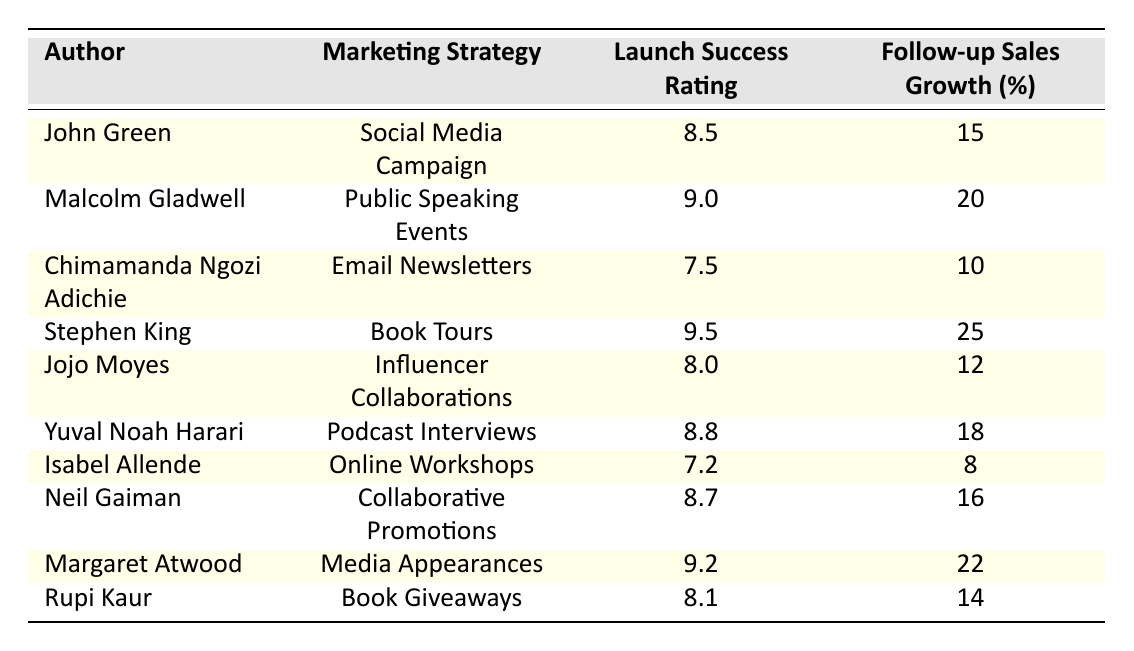What is the launch success rating for Stephen King? The table indicates that the launch success rating for Stephen King is listed as 9.5 in the corresponding row.
Answer: 9.5 Which author has the highest follow-up sales growth? Looking through the follow-up sales growth column, Stephen King has the highest value at 25%.
Answer: 25 Is Neil Gaiman's marketing strategy "Collaborative Promotions"? The table confirms that Neil Gaiman's marketing strategy is indeed "Collaborative Promotions" as stated in his corresponding row.
Answer: Yes What is the average launch success rating of the authors using Social Media Campaign and Email Newsletters? The authors using these strategies are John Green (8.5) and Chimamanda Ngozi Adichie (7.5). The average is calculated as (8.5 + 7.5) / 2 = 8.0.
Answer: 8.0 Which marketing strategy corresponds to the author with the lowest follow-up sales growth? The author with the lowest follow-up sales growth is Isabel Allende with 8%. The corresponding marketing strategy for Isabel Allende is "Online Workshops."
Answer: Online Workshops What is the difference in follow-up sales growth between Malcolm Gladwell and Rupi Kaur? From the table, Malcolm Gladwell has 20% and Rupi Kaur has 14%. The difference is calculated as 20 - 14 = 6%.
Answer: 6 Are the authors using Book Tours showing higher follow-up sales growth compared to those using Influencer Collaborations? Stephen King (Book Tours) shows 25% growth and Jojo Moyes (Influencer Collaborations) shows 12%. Since 25% is greater than 12%, the statement is true.
Answer: Yes What is the total follow-up sales growth for the authors with a launch success rating above 9.0? The authors with a success rating above 9.0 are Malcolm Gladwell (20%), Stephen King (25%), and Margaret Atwood (22%). Summing these gives 20 + 25 + 22 = 67%.
Answer: 67 How many authors used online marketing strategies such as Email Newsletters, Online Workshops, and Social Media Campaigns combined? The authors using these strategies are Chimamanda Ngozi Adichie, Isabel Allende, and John Green, respectively, summing to a total of 3 authors in these categories.
Answer: 3 